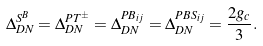<formula> <loc_0><loc_0><loc_500><loc_500>\Delta ^ { S ^ { B } } _ { D N } = \Delta ^ { P T ^ { \pm } } _ { D N } = \Delta ^ { P B _ { i j } } _ { D N } = \Delta ^ { P B S _ { i j } } _ { D N } = \frac { 2 g _ { c } } { 3 } .</formula> 